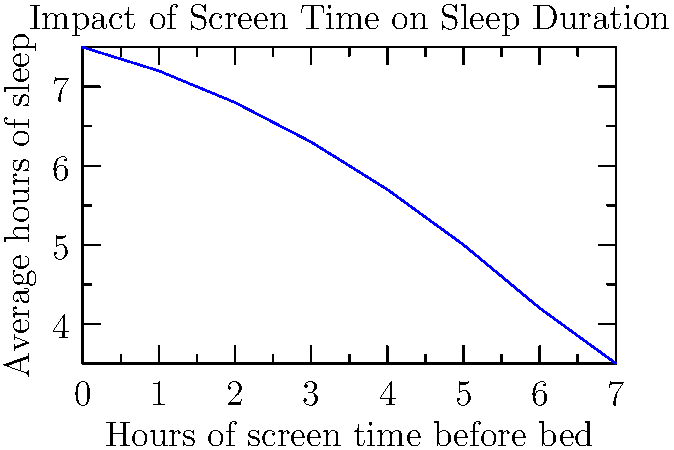Based on the graph, which shows the relationship between hours of screen time before bed and average hours of sleep, what is the approximate reduction in sleep duration for each additional hour of screen time? To determine the approximate reduction in sleep duration for each additional hour of screen time:

1. Identify two points on the graph:
   - At 0 hours of screen time: ~7.5 hours of sleep
   - At 7 hours of screen time: ~3.5 hours of sleep

2. Calculate the total reduction in sleep:
   $7.5 - 3.5 = 4$ hours

3. Calculate the rate of reduction per hour of screen time:
   $\frac{\text{Total reduction}}{\text{Total screen time}} = \frac{4 \text{ hours}}{7 \text{ hours}} \approx 0.57$ hours/hour

4. Convert to minutes:
   $0.57 \text{ hours} \times 60 \text{ minutes/hour} \approx 34$ minutes

Therefore, each additional hour of screen time before bed is associated with approximately 34 minutes less sleep.
Answer: 34 minutes 